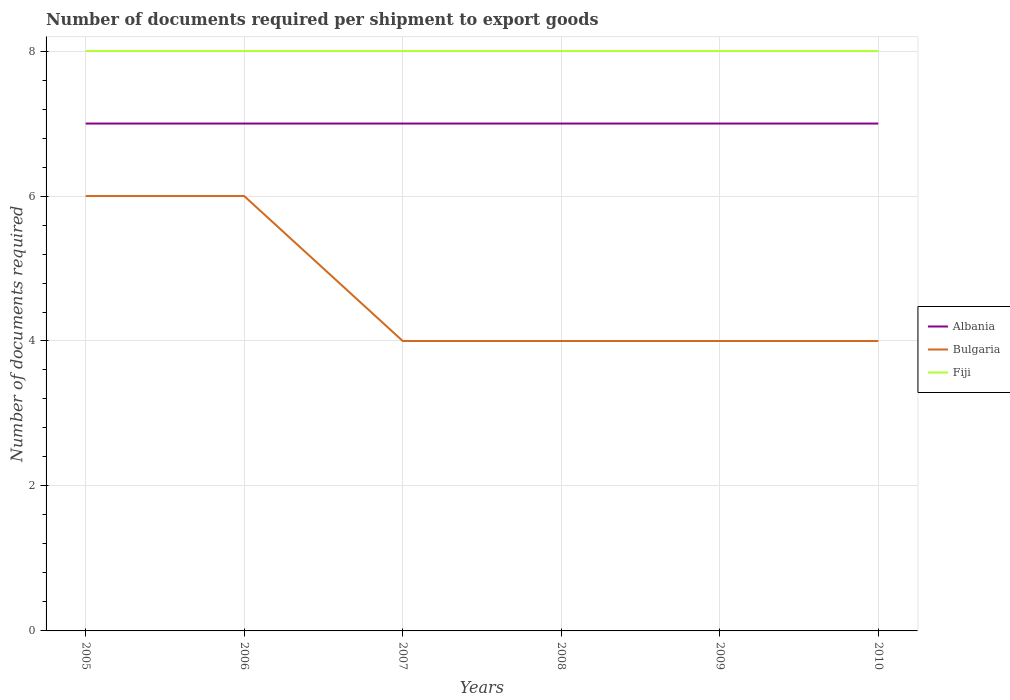Does the line corresponding to Bulgaria intersect with the line corresponding to Albania?
Your response must be concise. No. Across all years, what is the maximum number of documents required per shipment to export goods in Bulgaria?
Provide a short and direct response. 4. What is the difference between the highest and the second highest number of documents required per shipment to export goods in Bulgaria?
Give a very brief answer. 2. What is the difference between the highest and the lowest number of documents required per shipment to export goods in Albania?
Your response must be concise. 0. What is the difference between two consecutive major ticks on the Y-axis?
Your answer should be very brief. 2. Are the values on the major ticks of Y-axis written in scientific E-notation?
Give a very brief answer. No. Does the graph contain any zero values?
Provide a succinct answer. No. Where does the legend appear in the graph?
Your answer should be compact. Center right. How many legend labels are there?
Provide a succinct answer. 3. How are the legend labels stacked?
Offer a terse response. Vertical. What is the title of the graph?
Your answer should be compact. Number of documents required per shipment to export goods. What is the label or title of the X-axis?
Give a very brief answer. Years. What is the label or title of the Y-axis?
Make the answer very short. Number of documents required. What is the Number of documents required of Albania in 2005?
Ensure brevity in your answer.  7. What is the Number of documents required in Albania in 2006?
Your answer should be compact. 7. What is the Number of documents required in Bulgaria in 2006?
Provide a short and direct response. 6. What is the Number of documents required in Albania in 2007?
Give a very brief answer. 7. What is the Number of documents required of Albania in 2008?
Ensure brevity in your answer.  7. What is the Number of documents required of Bulgaria in 2008?
Ensure brevity in your answer.  4. What is the Number of documents required of Bulgaria in 2009?
Make the answer very short. 4. Across all years, what is the maximum Number of documents required of Albania?
Provide a short and direct response. 7. Across all years, what is the maximum Number of documents required in Bulgaria?
Keep it short and to the point. 6. Across all years, what is the maximum Number of documents required of Fiji?
Make the answer very short. 8. Across all years, what is the minimum Number of documents required in Albania?
Ensure brevity in your answer.  7. Across all years, what is the minimum Number of documents required of Fiji?
Keep it short and to the point. 8. What is the total Number of documents required of Bulgaria in the graph?
Provide a succinct answer. 28. What is the total Number of documents required in Fiji in the graph?
Your answer should be compact. 48. What is the difference between the Number of documents required of Fiji in 2005 and that in 2006?
Keep it short and to the point. 0. What is the difference between the Number of documents required of Albania in 2005 and that in 2007?
Ensure brevity in your answer.  0. What is the difference between the Number of documents required of Bulgaria in 2005 and that in 2007?
Keep it short and to the point. 2. What is the difference between the Number of documents required in Fiji in 2005 and that in 2007?
Ensure brevity in your answer.  0. What is the difference between the Number of documents required of Albania in 2005 and that in 2008?
Your answer should be compact. 0. What is the difference between the Number of documents required in Bulgaria in 2005 and that in 2008?
Offer a terse response. 2. What is the difference between the Number of documents required of Fiji in 2005 and that in 2008?
Offer a terse response. 0. What is the difference between the Number of documents required in Albania in 2005 and that in 2009?
Offer a terse response. 0. What is the difference between the Number of documents required of Bulgaria in 2005 and that in 2009?
Your answer should be very brief. 2. What is the difference between the Number of documents required of Bulgaria in 2005 and that in 2010?
Make the answer very short. 2. What is the difference between the Number of documents required of Bulgaria in 2006 and that in 2007?
Offer a very short reply. 2. What is the difference between the Number of documents required of Fiji in 2006 and that in 2007?
Your answer should be very brief. 0. What is the difference between the Number of documents required in Albania in 2006 and that in 2008?
Give a very brief answer. 0. What is the difference between the Number of documents required in Bulgaria in 2006 and that in 2008?
Your answer should be very brief. 2. What is the difference between the Number of documents required of Fiji in 2006 and that in 2008?
Provide a short and direct response. 0. What is the difference between the Number of documents required in Albania in 2006 and that in 2009?
Ensure brevity in your answer.  0. What is the difference between the Number of documents required in Bulgaria in 2006 and that in 2009?
Offer a very short reply. 2. What is the difference between the Number of documents required in Bulgaria in 2006 and that in 2010?
Provide a succinct answer. 2. What is the difference between the Number of documents required of Fiji in 2007 and that in 2008?
Give a very brief answer. 0. What is the difference between the Number of documents required of Albania in 2007 and that in 2009?
Your answer should be very brief. 0. What is the difference between the Number of documents required of Albania in 2007 and that in 2010?
Offer a terse response. 0. What is the difference between the Number of documents required of Fiji in 2007 and that in 2010?
Keep it short and to the point. 0. What is the difference between the Number of documents required of Albania in 2008 and that in 2009?
Make the answer very short. 0. What is the difference between the Number of documents required of Fiji in 2008 and that in 2009?
Your answer should be very brief. 0. What is the difference between the Number of documents required in Albania in 2008 and that in 2010?
Give a very brief answer. 0. What is the difference between the Number of documents required of Fiji in 2008 and that in 2010?
Your answer should be compact. 0. What is the difference between the Number of documents required of Albania in 2009 and that in 2010?
Provide a short and direct response. 0. What is the difference between the Number of documents required in Bulgaria in 2009 and that in 2010?
Offer a very short reply. 0. What is the difference between the Number of documents required in Fiji in 2009 and that in 2010?
Provide a succinct answer. 0. What is the difference between the Number of documents required of Albania in 2005 and the Number of documents required of Bulgaria in 2006?
Offer a terse response. 1. What is the difference between the Number of documents required of Bulgaria in 2005 and the Number of documents required of Fiji in 2006?
Give a very brief answer. -2. What is the difference between the Number of documents required of Albania in 2005 and the Number of documents required of Bulgaria in 2007?
Offer a terse response. 3. What is the difference between the Number of documents required of Bulgaria in 2005 and the Number of documents required of Fiji in 2008?
Offer a terse response. -2. What is the difference between the Number of documents required in Albania in 2005 and the Number of documents required in Bulgaria in 2009?
Ensure brevity in your answer.  3. What is the difference between the Number of documents required in Albania in 2005 and the Number of documents required in Bulgaria in 2010?
Offer a terse response. 3. What is the difference between the Number of documents required in Albania in 2005 and the Number of documents required in Fiji in 2010?
Provide a short and direct response. -1. What is the difference between the Number of documents required in Bulgaria in 2006 and the Number of documents required in Fiji in 2007?
Offer a very short reply. -2. What is the difference between the Number of documents required of Bulgaria in 2006 and the Number of documents required of Fiji in 2008?
Give a very brief answer. -2. What is the difference between the Number of documents required in Bulgaria in 2006 and the Number of documents required in Fiji in 2009?
Ensure brevity in your answer.  -2. What is the difference between the Number of documents required of Albania in 2007 and the Number of documents required of Fiji in 2008?
Offer a terse response. -1. What is the difference between the Number of documents required in Albania in 2007 and the Number of documents required in Bulgaria in 2010?
Give a very brief answer. 3. What is the difference between the Number of documents required of Albania in 2007 and the Number of documents required of Fiji in 2010?
Offer a very short reply. -1. What is the difference between the Number of documents required in Albania in 2008 and the Number of documents required in Bulgaria in 2009?
Offer a terse response. 3. What is the difference between the Number of documents required in Albania in 2008 and the Number of documents required in Fiji in 2009?
Provide a succinct answer. -1. What is the difference between the Number of documents required of Bulgaria in 2008 and the Number of documents required of Fiji in 2009?
Offer a terse response. -4. What is the difference between the Number of documents required of Albania in 2008 and the Number of documents required of Bulgaria in 2010?
Your answer should be compact. 3. What is the difference between the Number of documents required in Albania in 2008 and the Number of documents required in Fiji in 2010?
Give a very brief answer. -1. What is the difference between the Number of documents required in Bulgaria in 2008 and the Number of documents required in Fiji in 2010?
Provide a short and direct response. -4. What is the difference between the Number of documents required of Albania in 2009 and the Number of documents required of Bulgaria in 2010?
Your response must be concise. 3. What is the average Number of documents required of Bulgaria per year?
Give a very brief answer. 4.67. In the year 2005, what is the difference between the Number of documents required in Albania and Number of documents required in Bulgaria?
Provide a short and direct response. 1. In the year 2005, what is the difference between the Number of documents required of Albania and Number of documents required of Fiji?
Provide a succinct answer. -1. In the year 2006, what is the difference between the Number of documents required of Albania and Number of documents required of Fiji?
Offer a very short reply. -1. In the year 2007, what is the difference between the Number of documents required of Albania and Number of documents required of Bulgaria?
Your response must be concise. 3. In the year 2007, what is the difference between the Number of documents required of Albania and Number of documents required of Fiji?
Offer a terse response. -1. In the year 2007, what is the difference between the Number of documents required of Bulgaria and Number of documents required of Fiji?
Keep it short and to the point. -4. In the year 2008, what is the difference between the Number of documents required in Albania and Number of documents required in Bulgaria?
Keep it short and to the point. 3. In the year 2008, what is the difference between the Number of documents required in Albania and Number of documents required in Fiji?
Keep it short and to the point. -1. In the year 2008, what is the difference between the Number of documents required in Bulgaria and Number of documents required in Fiji?
Your answer should be very brief. -4. In the year 2009, what is the difference between the Number of documents required of Albania and Number of documents required of Bulgaria?
Your response must be concise. 3. In the year 2010, what is the difference between the Number of documents required of Albania and Number of documents required of Fiji?
Keep it short and to the point. -1. In the year 2010, what is the difference between the Number of documents required in Bulgaria and Number of documents required in Fiji?
Keep it short and to the point. -4. What is the ratio of the Number of documents required of Albania in 2005 to that in 2006?
Keep it short and to the point. 1. What is the ratio of the Number of documents required in Bulgaria in 2005 to that in 2006?
Your answer should be very brief. 1. What is the ratio of the Number of documents required of Fiji in 2005 to that in 2007?
Give a very brief answer. 1. What is the ratio of the Number of documents required in Bulgaria in 2005 to that in 2008?
Provide a short and direct response. 1.5. What is the ratio of the Number of documents required in Bulgaria in 2005 to that in 2009?
Provide a short and direct response. 1.5. What is the ratio of the Number of documents required of Fiji in 2005 to that in 2009?
Ensure brevity in your answer.  1. What is the ratio of the Number of documents required in Fiji in 2005 to that in 2010?
Offer a terse response. 1. What is the ratio of the Number of documents required in Albania in 2006 to that in 2007?
Keep it short and to the point. 1. What is the ratio of the Number of documents required in Bulgaria in 2006 to that in 2009?
Give a very brief answer. 1.5. What is the ratio of the Number of documents required in Albania in 2006 to that in 2010?
Give a very brief answer. 1. What is the ratio of the Number of documents required of Bulgaria in 2006 to that in 2010?
Offer a terse response. 1.5. What is the ratio of the Number of documents required in Bulgaria in 2007 to that in 2008?
Your response must be concise. 1. What is the ratio of the Number of documents required in Bulgaria in 2007 to that in 2009?
Your answer should be very brief. 1. What is the ratio of the Number of documents required in Fiji in 2007 to that in 2009?
Make the answer very short. 1. What is the ratio of the Number of documents required in Albania in 2007 to that in 2010?
Your response must be concise. 1. What is the ratio of the Number of documents required of Bulgaria in 2007 to that in 2010?
Your answer should be compact. 1. What is the ratio of the Number of documents required in Fiji in 2007 to that in 2010?
Provide a short and direct response. 1. What is the ratio of the Number of documents required of Albania in 2008 to that in 2009?
Give a very brief answer. 1. What is the ratio of the Number of documents required in Bulgaria in 2008 to that in 2009?
Your answer should be very brief. 1. What is the ratio of the Number of documents required of Fiji in 2008 to that in 2009?
Your response must be concise. 1. What is the ratio of the Number of documents required of Bulgaria in 2008 to that in 2010?
Provide a succinct answer. 1. What is the ratio of the Number of documents required of Fiji in 2008 to that in 2010?
Make the answer very short. 1. What is the ratio of the Number of documents required of Albania in 2009 to that in 2010?
Your answer should be very brief. 1. What is the ratio of the Number of documents required of Bulgaria in 2009 to that in 2010?
Offer a very short reply. 1. What is the ratio of the Number of documents required of Fiji in 2009 to that in 2010?
Keep it short and to the point. 1. What is the difference between the highest and the second highest Number of documents required of Albania?
Ensure brevity in your answer.  0. What is the difference between the highest and the second highest Number of documents required of Bulgaria?
Ensure brevity in your answer.  0. What is the difference between the highest and the second highest Number of documents required of Fiji?
Ensure brevity in your answer.  0. What is the difference between the highest and the lowest Number of documents required in Bulgaria?
Provide a short and direct response. 2. 